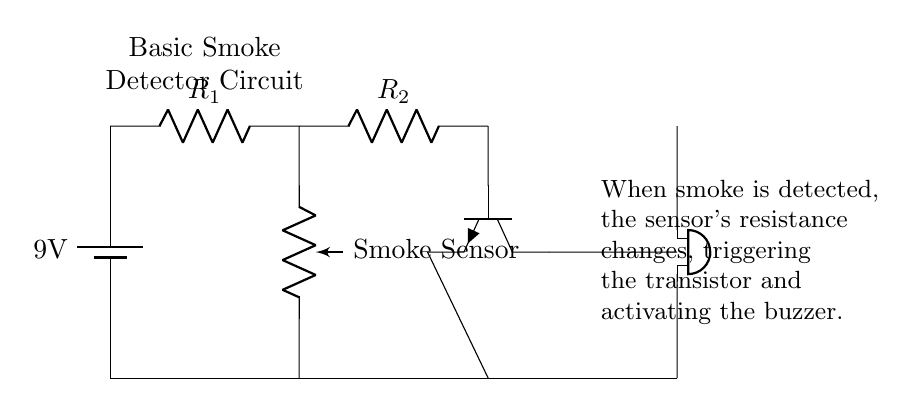What is the voltage of the power supply? The circuit has a power supply indicated by a battery symbol labeled with 9V, which shows the voltage provided to the circuit.
Answer: 9 volts What type of sensor is used in this circuit? The circuit diagram labels a component as a "Smoke Sensor," indicating the type of sensor used to detect smoke.
Answer: Smoke Sensor How many resistors are in the circuit? The circuit shows two resistors labeled R1 and R2, indicating that there are two in total.
Answer: Two What component is activated when smoke is detected? The circuit shows a buzzer connected to the transistor, which will activate the buzzer when smoke is detected through the change in resistance of the smoke sensor.
Answer: Buzzer What is the role of the transistor in this circuit? The transistor is connected to the smoke sensor and the buzzer. When smoke is detected, the sensor changes resistance, triggering the transistor to allow current to flow and activate the buzzer.
Answer: Switch What does the smoke sensor do when smoke is present? The smoke sensor changes its resistance when it detects smoke, which is the trigger for the transistor to activate the buzzer in this circuit.
Answer: Changes resistance Which component provides the current for the circuit? The circuit clearly identifies a battery as the power supply, which provides the necessary current for the operation of the rest of the circuit components.
Answer: Battery 